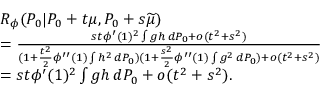Convert formula to latex. <formula><loc_0><loc_0><loc_500><loc_500>\begin{array} { r l } & { { R _ { \phi } } ( P _ { 0 } | P _ { 0 } + t \mu , P _ { 0 } + s \widetilde { \mu } ) } \\ & { = \frac { s t \phi ^ { \prime } ( 1 ) ^ { 2 } \int g h \, d P _ { 0 } + o ( t ^ { 2 } + s ^ { 2 } ) } { ( 1 + \frac { t ^ { 2 } } { 2 } \phi ^ { \prime \prime } ( 1 ) \int h ^ { 2 } \, d P _ { 0 } ) ( 1 + \frac { s ^ { 2 } } { 2 } \phi ^ { \prime \prime } ( 1 ) \int g ^ { 2 } \, d P _ { 0 } ) + o ( t ^ { 2 } + s ^ { 2 } ) } } \\ & { = s t \phi ^ { \prime } ( 1 ) ^ { 2 } \int g h \, d P _ { 0 } + o ( t ^ { 2 } + s ^ { 2 } ) . } \end{array}</formula> 